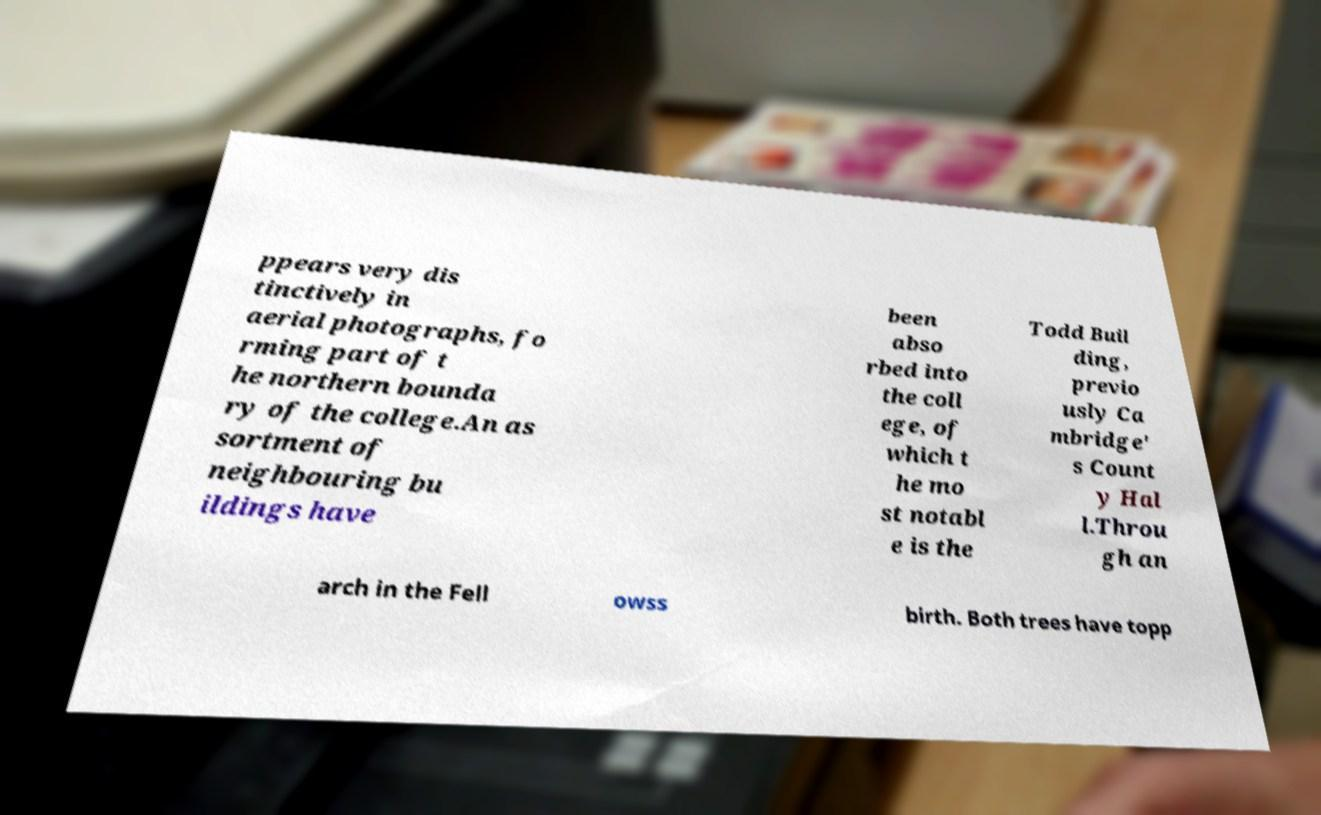Please identify and transcribe the text found in this image. ppears very dis tinctively in aerial photographs, fo rming part of t he northern bounda ry of the college.An as sortment of neighbouring bu ildings have been abso rbed into the coll ege, of which t he mo st notabl e is the Todd Buil ding, previo usly Ca mbridge' s Count y Hal l.Throu gh an arch in the Fell owss birth. Both trees have topp 